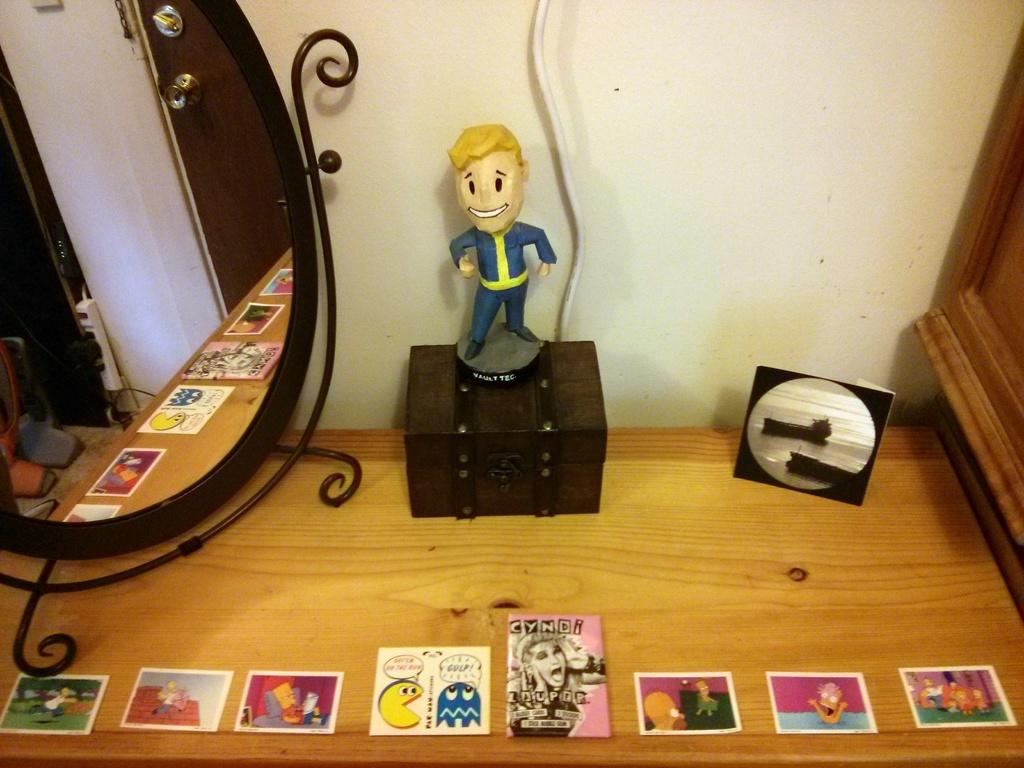What object is located on the left side of the image? There is a mirror on the left side of the image. What is the doll's position in the image? The doll is placed on a box in the image. What type of furniture is in the image? There is a wooden table in the image. What items are on the wooden table? Cards are present on the wooden table. Where is the sink located in the image? There is no sink present in the image. Can you tell me how many matches are on the wooden table? There is no mention of matches in the image; only cards are present on the wooden table. 